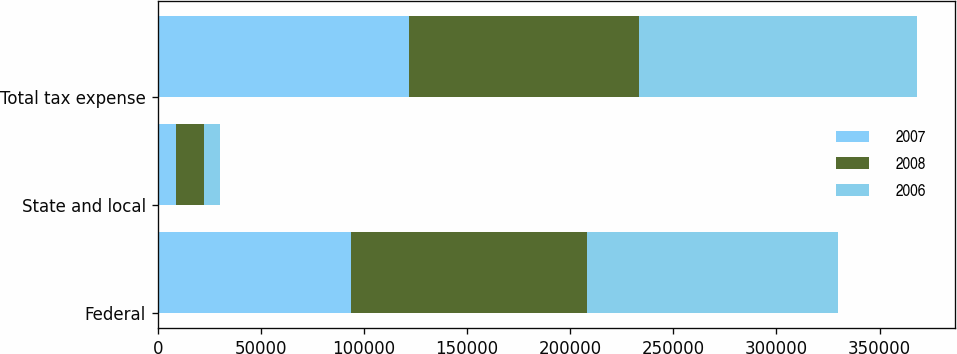Convert chart to OTSL. <chart><loc_0><loc_0><loc_500><loc_500><stacked_bar_chart><ecel><fcel>Federal<fcel>State and local<fcel>Total tax expense<nl><fcel>2007<fcel>93699<fcel>8985<fcel>121643<nl><fcel>2008<fcel>114499<fcel>13462<fcel>111913<nl><fcel>2006<fcel>121855<fcel>7781<fcel>134361<nl></chart> 